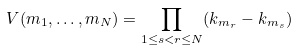<formula> <loc_0><loc_0><loc_500><loc_500>V ( m _ { 1 } , \dots , m _ { N } ) = \prod _ { 1 \leq s < r \leq N } ( k _ { m _ { r } } - k _ { m _ { s } } ) \,</formula> 